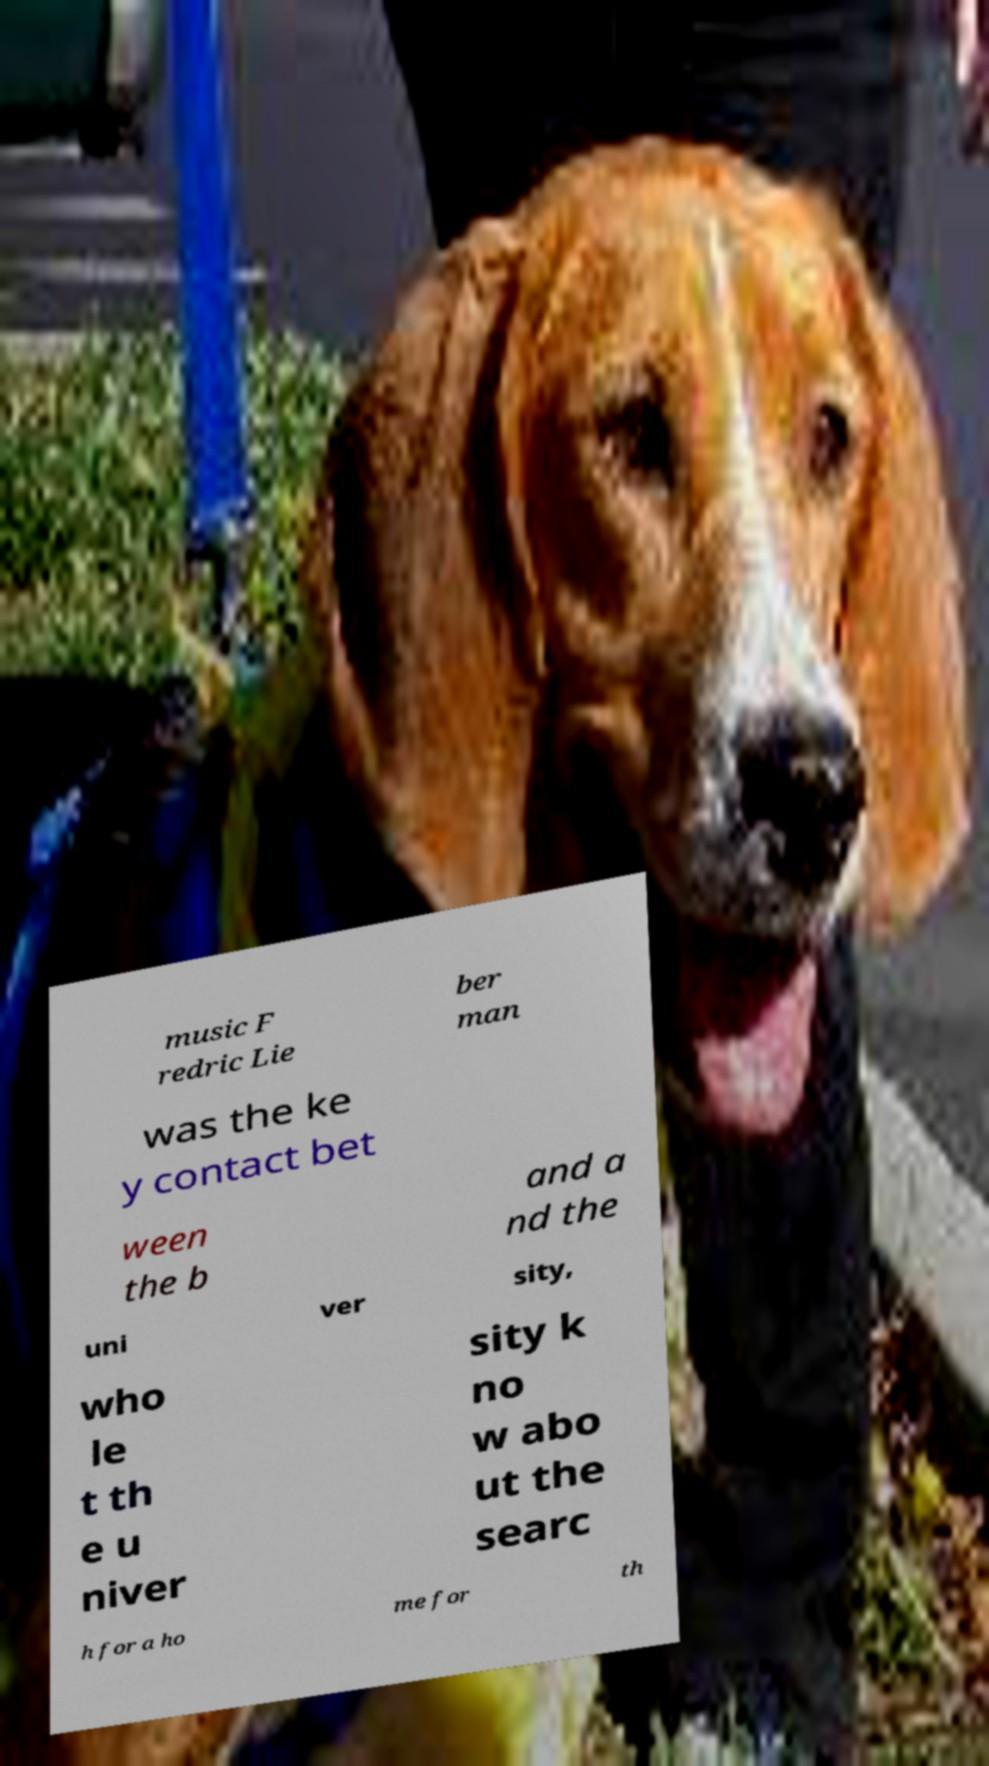There's text embedded in this image that I need extracted. Can you transcribe it verbatim? music F redric Lie ber man was the ke y contact bet ween the b and a nd the uni ver sity, who le t th e u niver sity k no w abo ut the searc h for a ho me for th 